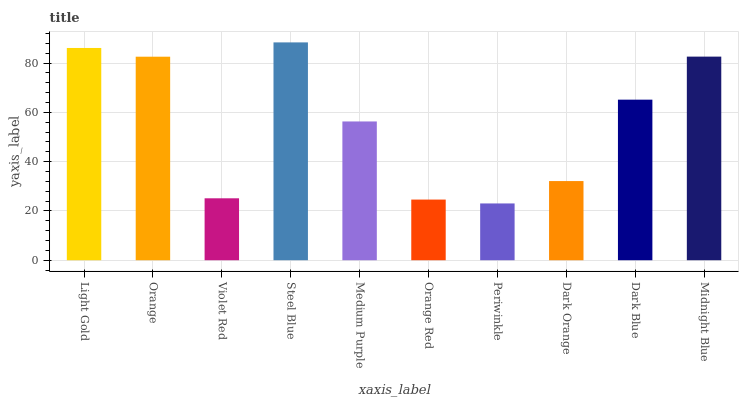Is Orange the minimum?
Answer yes or no. No. Is Orange the maximum?
Answer yes or no. No. Is Light Gold greater than Orange?
Answer yes or no. Yes. Is Orange less than Light Gold?
Answer yes or no. Yes. Is Orange greater than Light Gold?
Answer yes or no. No. Is Light Gold less than Orange?
Answer yes or no. No. Is Dark Blue the high median?
Answer yes or no. Yes. Is Medium Purple the low median?
Answer yes or no. Yes. Is Midnight Blue the high median?
Answer yes or no. No. Is Orange Red the low median?
Answer yes or no. No. 